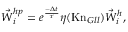<formula> <loc_0><loc_0><loc_500><loc_500>{ \vec { W } } _ { i } ^ { h p } = e ^ { \frac { - \Delta t } { \tau } } \eta ( { K n } _ { G l l } ) { \vec { W } } _ { i } ^ { h } ,</formula> 